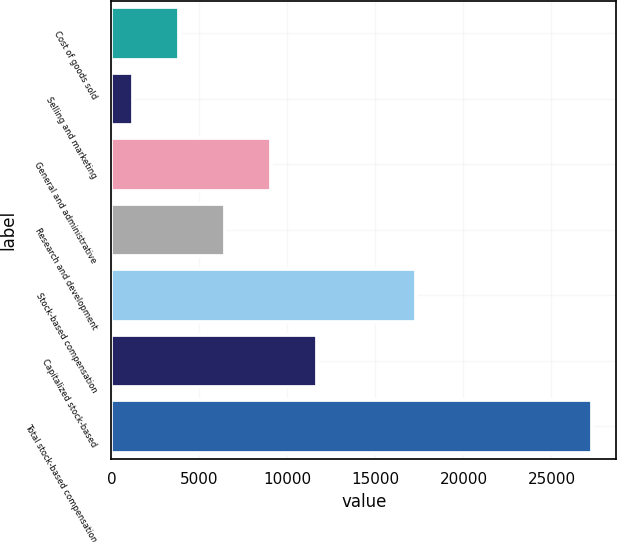<chart> <loc_0><loc_0><loc_500><loc_500><bar_chart><fcel>Cost of goods sold<fcel>Selling and marketing<fcel>General and administrative<fcel>Research and development<fcel>Stock-based compensation<fcel>Capitalized stock-based<fcel>Total stock-based compensation<nl><fcel>3840<fcel>1232<fcel>9056<fcel>6448<fcel>17329<fcel>11664<fcel>27312<nl></chart> 